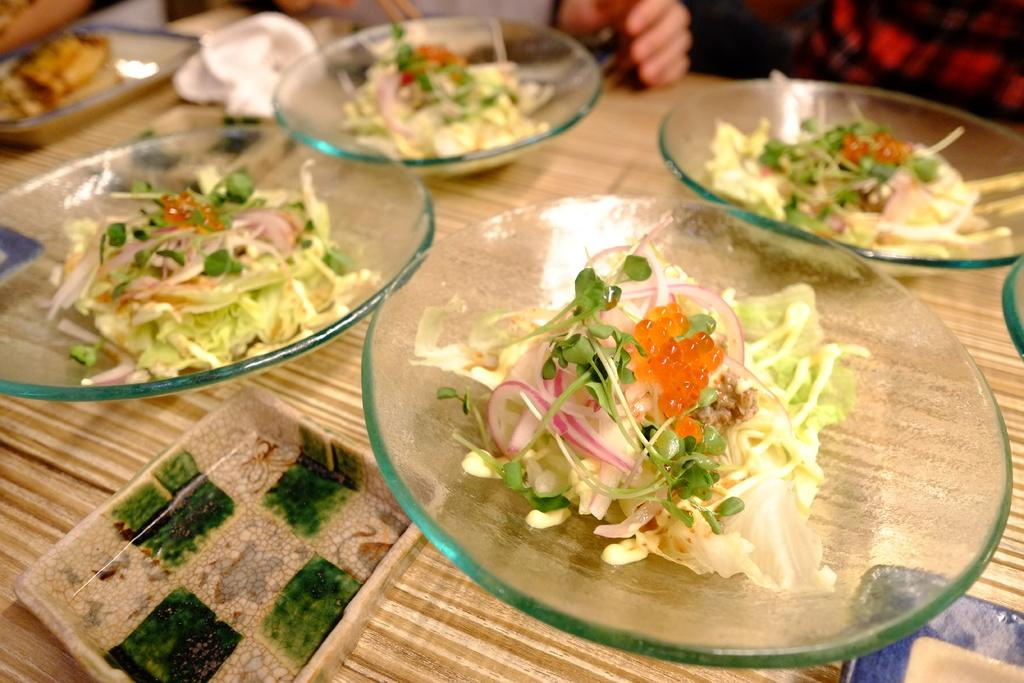What is present on the plates in the image? There is food in the plates in the image. How are the plates arranged in the image? The plates are on a tray in the image. What is covering the table in the image? There is a cloth on the table in the image. Can you describe the person in the background of the image? There is a person in the background of the image, but no specific details are provided. What type of animal can be seen sailing the ship in the image? There is no animal or ship present in the image; it features food on plates, a tray, a cloth on the table, and a person in the background. 